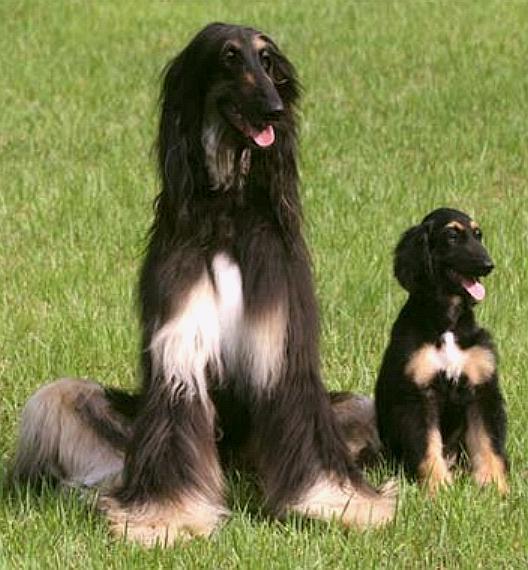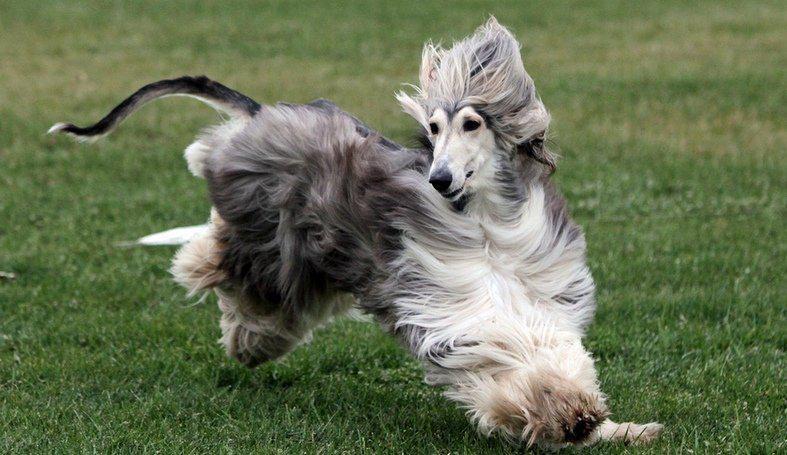The first image is the image on the left, the second image is the image on the right. Evaluate the accuracy of this statement regarding the images: "There is a dog running in one of the images.". Is it true? Answer yes or no. Yes. The first image is the image on the left, the second image is the image on the right. Analyze the images presented: Is the assertion "One image shows a hound bounding across the grass." valid? Answer yes or no. Yes. 